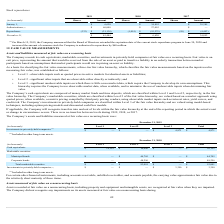According to Pegasystems's financial document, Where are investments in privately-held companies classified under? Included in other long-term assets. The document states: "(1) Included in other long-term assets...." Also, What are the respective Level 1 and Level 2 cash equivalents as at December 31, 2018? The document shows two values: $10,155 and $10,000. From the document: "Cash equivalents $ 10,155 $ 10,000 $ — $ 20,155 Cash equivalents $ 10,155 $ 10,000 $ — $ 20,155..." Also, What are the respective Level 2 municipal and corporate bonds as at December 31, 2018? The document shows two values: $44,705 and $48,296. From the document: "Corporate bonds — 48,296 — 48,296 Municipal bonds $ — $ 44,705 $ — $ 44,705..." Also, can you calculate: What is the value of Level 1 cash equivalents as a percentage of the total cash equivalents? Based on the calculation: 10,155/20,155 , the result is 50.38 (percentage). This is based on the information: "Cash equivalents $ 10,155 $ 10,000 $ — $ 20,155 Cash equivalents $ 10,155 $ 10,000 $ — $ 20,155..." The key data points involved are: 10,155, 20,155. Also, can you calculate: What is the value of Level 2 municipal bonds as a percentage of the total municipal bonds? Based on the calculation: 44,705/44,705 , the result is 100 (percentage). This is based on the information: "Municipal bonds $ — $ 44,705 $ — $ 44,705..." Also, can you calculate: What is the value of municipal bonds as a percentage of the total marketable securities? Based on the calculation: 44,705/93,001 , the result is 48.07 (percentage). This is based on the information: "Total marketable securities $ — $ 93,001 $ — $ 93,001 Municipal bonds $ — $ 44,705 $ — $ 44,705..." The key data points involved are: 44,705, 93,001. 